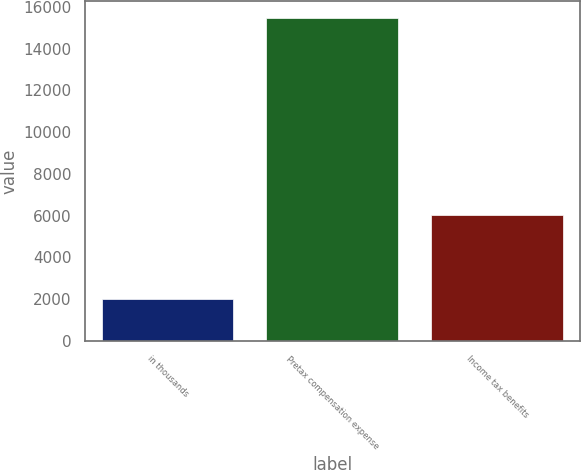<chart> <loc_0><loc_0><loc_500><loc_500><bar_chart><fcel>in thousands<fcel>Pretax compensation expense<fcel>Income tax benefits<nl><fcel>2012<fcel>15491<fcel>6011<nl></chart> 